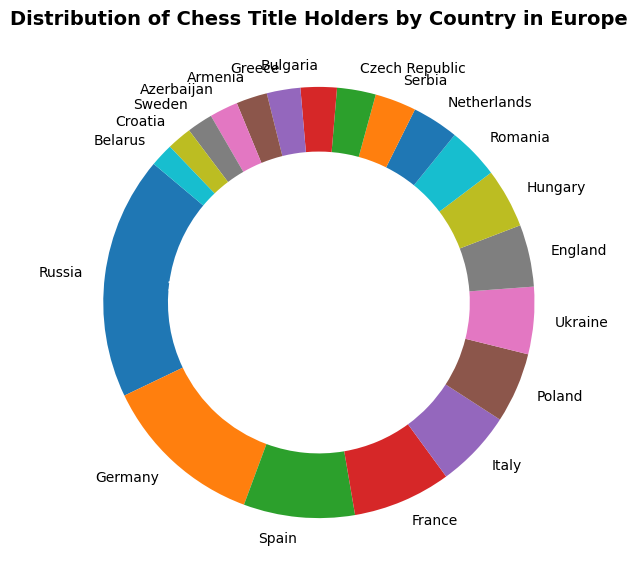Which country has the highest number of chess title holders? Look at the sector with the largest size and the highest percentage. The label on this sector indicates the country with the most title holders.
Answer: Russia Which three countries have the fewest title holders? Look for the three smallest segments in the ring chart and read their labels to identify the countries.
Answer: Belarus, Croatia, Sweden Is Spain ahead of France in terms of chess title holders? Compare the sizes and percentages of the segments representing Spain and France. Spain's percentage is visually larger than France's percentage.
Answer: Yes Which country in the ring chart is in the fourth position in terms of the number of chess title holders? Identify and count the segments visually in descending order from the largest to the smallest. The fourth segment will give the country in the fourth position.
Answer: France 